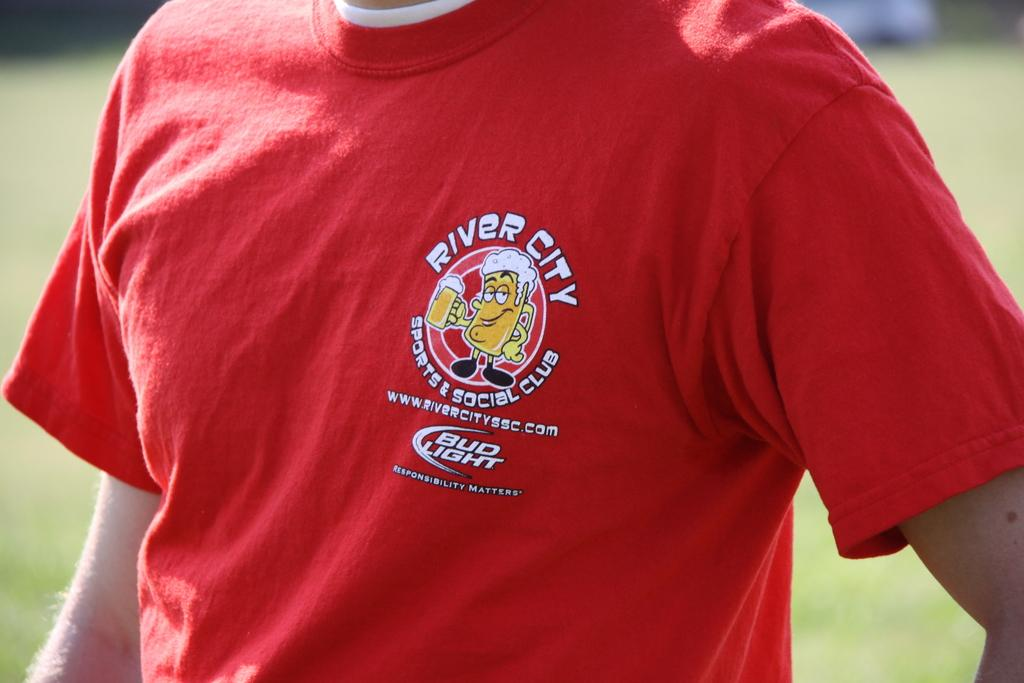<image>
Render a clear and concise summary of the photo. a person with a shirt on that says River City on it 